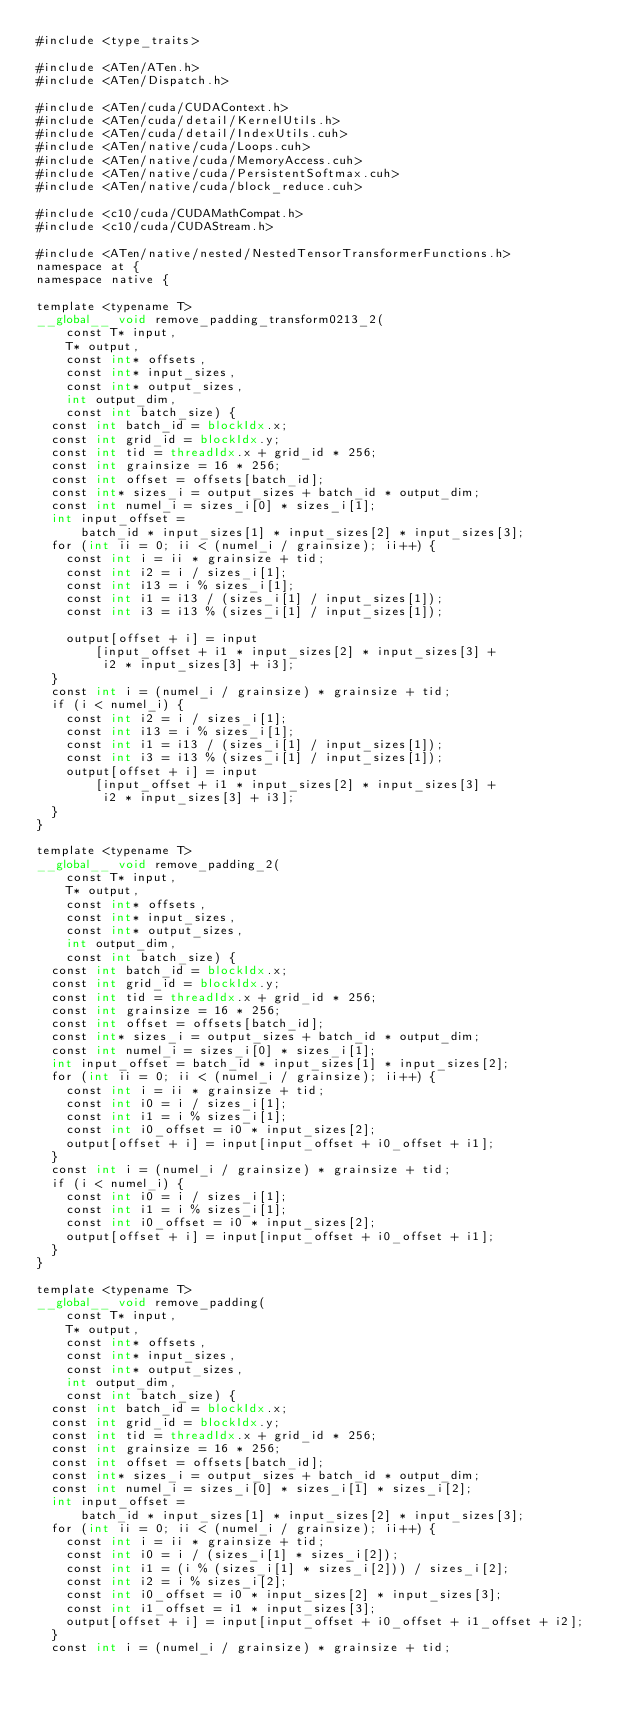Convert code to text. <code><loc_0><loc_0><loc_500><loc_500><_Cuda_>#include <type_traits>

#include <ATen/ATen.h>
#include <ATen/Dispatch.h>

#include <ATen/cuda/CUDAContext.h>
#include <ATen/cuda/detail/KernelUtils.h>
#include <ATen/cuda/detail/IndexUtils.cuh>
#include <ATen/native/cuda/Loops.cuh>
#include <ATen/native/cuda/MemoryAccess.cuh>
#include <ATen/native/cuda/PersistentSoftmax.cuh>
#include <ATen/native/cuda/block_reduce.cuh>

#include <c10/cuda/CUDAMathCompat.h>
#include <c10/cuda/CUDAStream.h>

#include <ATen/native/nested/NestedTensorTransformerFunctions.h>
namespace at {
namespace native {

template <typename T>
__global__ void remove_padding_transform0213_2(
    const T* input,
    T* output,
    const int* offsets,
    const int* input_sizes,
    const int* output_sizes,
    int output_dim,
    const int batch_size) {
  const int batch_id = blockIdx.x;
  const int grid_id = blockIdx.y;
  const int tid = threadIdx.x + grid_id * 256;
  const int grainsize = 16 * 256;
  const int offset = offsets[batch_id];
  const int* sizes_i = output_sizes + batch_id * output_dim;
  const int numel_i = sizes_i[0] * sizes_i[1];
  int input_offset =
      batch_id * input_sizes[1] * input_sizes[2] * input_sizes[3];
  for (int ii = 0; ii < (numel_i / grainsize); ii++) {
    const int i = ii * grainsize + tid;
    const int i2 = i / sizes_i[1];
    const int i13 = i % sizes_i[1];
    const int i1 = i13 / (sizes_i[1] / input_sizes[1]);
    const int i3 = i13 % (sizes_i[1] / input_sizes[1]);

    output[offset + i] = input
        [input_offset + i1 * input_sizes[2] * input_sizes[3] +
         i2 * input_sizes[3] + i3];
  }
  const int i = (numel_i / grainsize) * grainsize + tid;
  if (i < numel_i) {
    const int i2 = i / sizes_i[1];
    const int i13 = i % sizes_i[1];
    const int i1 = i13 / (sizes_i[1] / input_sizes[1]);
    const int i3 = i13 % (sizes_i[1] / input_sizes[1]);
    output[offset + i] = input
        [input_offset + i1 * input_sizes[2] * input_sizes[3] +
         i2 * input_sizes[3] + i3];
  }
}

template <typename T>
__global__ void remove_padding_2(
    const T* input,
    T* output,
    const int* offsets,
    const int* input_sizes,
    const int* output_sizes,
    int output_dim,
    const int batch_size) {
  const int batch_id = blockIdx.x;
  const int grid_id = blockIdx.y;
  const int tid = threadIdx.x + grid_id * 256;
  const int grainsize = 16 * 256;
  const int offset = offsets[batch_id];
  const int* sizes_i = output_sizes + batch_id * output_dim;
  const int numel_i = sizes_i[0] * sizes_i[1];
  int input_offset = batch_id * input_sizes[1] * input_sizes[2];
  for (int ii = 0; ii < (numel_i / grainsize); ii++) {
    const int i = ii * grainsize + tid;
    const int i0 = i / sizes_i[1];
    const int i1 = i % sizes_i[1];
    const int i0_offset = i0 * input_sizes[2];
    output[offset + i] = input[input_offset + i0_offset + i1];
  }
  const int i = (numel_i / grainsize) * grainsize + tid;
  if (i < numel_i) {
    const int i0 = i / sizes_i[1];
    const int i1 = i % sizes_i[1];
    const int i0_offset = i0 * input_sizes[2];
    output[offset + i] = input[input_offset + i0_offset + i1];
  }
}

template <typename T>
__global__ void remove_padding(
    const T* input,
    T* output,
    const int* offsets,
    const int* input_sizes,
    const int* output_sizes,
    int output_dim,
    const int batch_size) {
  const int batch_id = blockIdx.x;
  const int grid_id = blockIdx.y;
  const int tid = threadIdx.x + grid_id * 256;
  const int grainsize = 16 * 256;
  const int offset = offsets[batch_id];
  const int* sizes_i = output_sizes + batch_id * output_dim;
  const int numel_i = sizes_i[0] * sizes_i[1] * sizes_i[2];
  int input_offset =
      batch_id * input_sizes[1] * input_sizes[2] * input_sizes[3];
  for (int ii = 0; ii < (numel_i / grainsize); ii++) {
    const int i = ii * grainsize + tid;
    const int i0 = i / (sizes_i[1] * sizes_i[2]);
    const int i1 = (i % (sizes_i[1] * sizes_i[2])) / sizes_i[2];
    const int i2 = i % sizes_i[2];
    const int i0_offset = i0 * input_sizes[2] * input_sizes[3];
    const int i1_offset = i1 * input_sizes[3];
    output[offset + i] = input[input_offset + i0_offset + i1_offset + i2];
  }
  const int i = (numel_i / grainsize) * grainsize + tid;</code> 